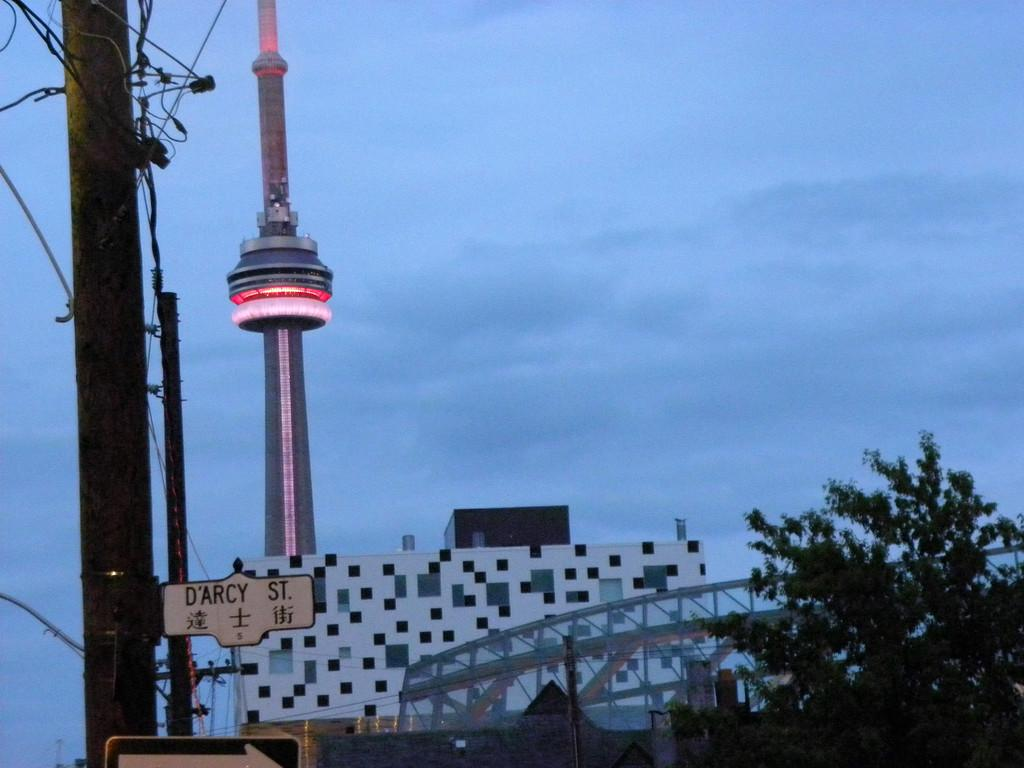What type of structure is present in the image? There is a building in the image. What other objects can be seen in the image? There is a pole, a tower, electric wires, trees, and a board with text in the image. What is the weather like in the image? The sky is cloudy in the image. How many children are playing with the father in the image? There are no children or father present in the image. What type of books can be found in the library depicted in the image? There is no library depicted in the image. 